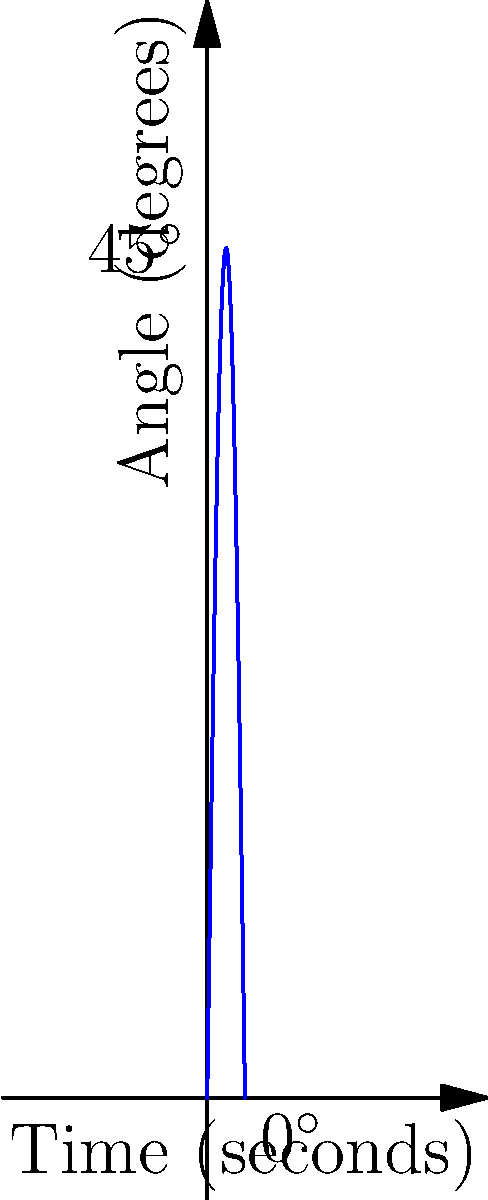During the prostration in prayer, the angle of the forehead to the ground changes over time. The graph shows this angle θ as a function of time t, where θ = 45sin(πt/2) degrees and t is in seconds. At what time does the forehead first touch the ground (θ = 0°) during the prostration movement? To find when the forehead first touches the ground, we need to solve the equation:

1) θ = 45sin(πt/2) = 0

2) This occurs when sin(πt/2) = 0

3) The sine function equals zero when its argument is a multiple of π:
   πt/2 = nπ, where n is an integer

4) For the first touch, we want the smallest positive value of t, so n = 1:
   πt/2 = π

5) Solving for t:
   t = 2π/π = 2 seconds

Therefore, the forehead first touches the ground after 2 seconds.
Answer: 2 seconds 